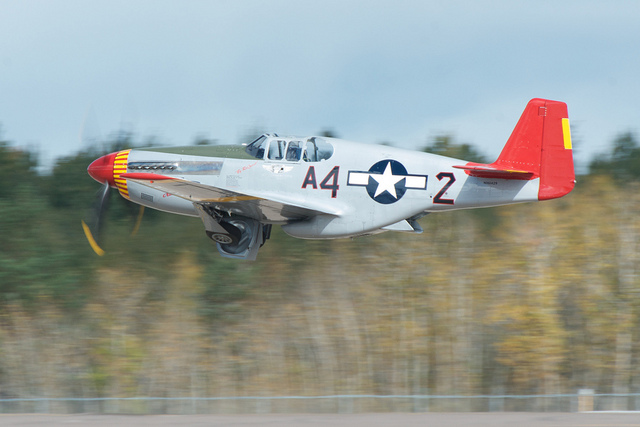What could one deduce about the aircraft's operation based on its appearance? Given the aircraft's pristine condition and civilian registration number, one could deduce that it is likely operated as a preserved historical aircraft, possibly for airshows and commemorative events, rather than for military purposes. What are those colors on the tail of the aircraft? The red tail with a yellow stripe is indicative of the Tuskegee Airmen's aircraft, who were a group of African American fighter pilots in the U.S. Army Air Corps during World War II. These colors were part of the distinctive livery used to identify their planes. 